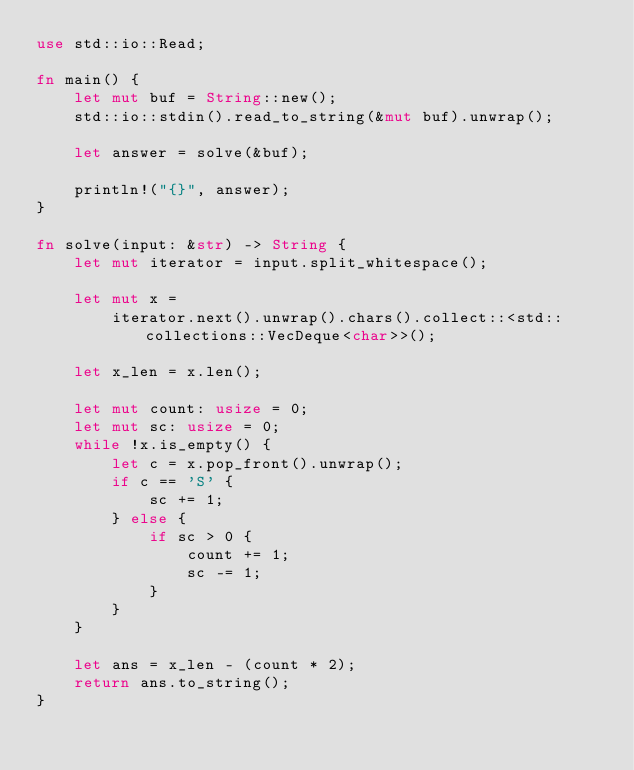<code> <loc_0><loc_0><loc_500><loc_500><_Rust_>use std::io::Read;

fn main() {
    let mut buf = String::new();
    std::io::stdin().read_to_string(&mut buf).unwrap();

    let answer = solve(&buf);

    println!("{}", answer);
}

fn solve(input: &str) -> String {
    let mut iterator = input.split_whitespace();

    let mut x =
        iterator.next().unwrap().chars().collect::<std::collections::VecDeque<char>>();

    let x_len = x.len();

    let mut count: usize = 0;
    let mut sc: usize = 0;
    while !x.is_empty() {
        let c = x.pop_front().unwrap();
        if c == 'S' {
            sc += 1;
        } else {
            if sc > 0 {
                count += 1;
                sc -= 1;
            }
        }
    }

    let ans = x_len - (count * 2);
    return ans.to_string();
}
</code> 